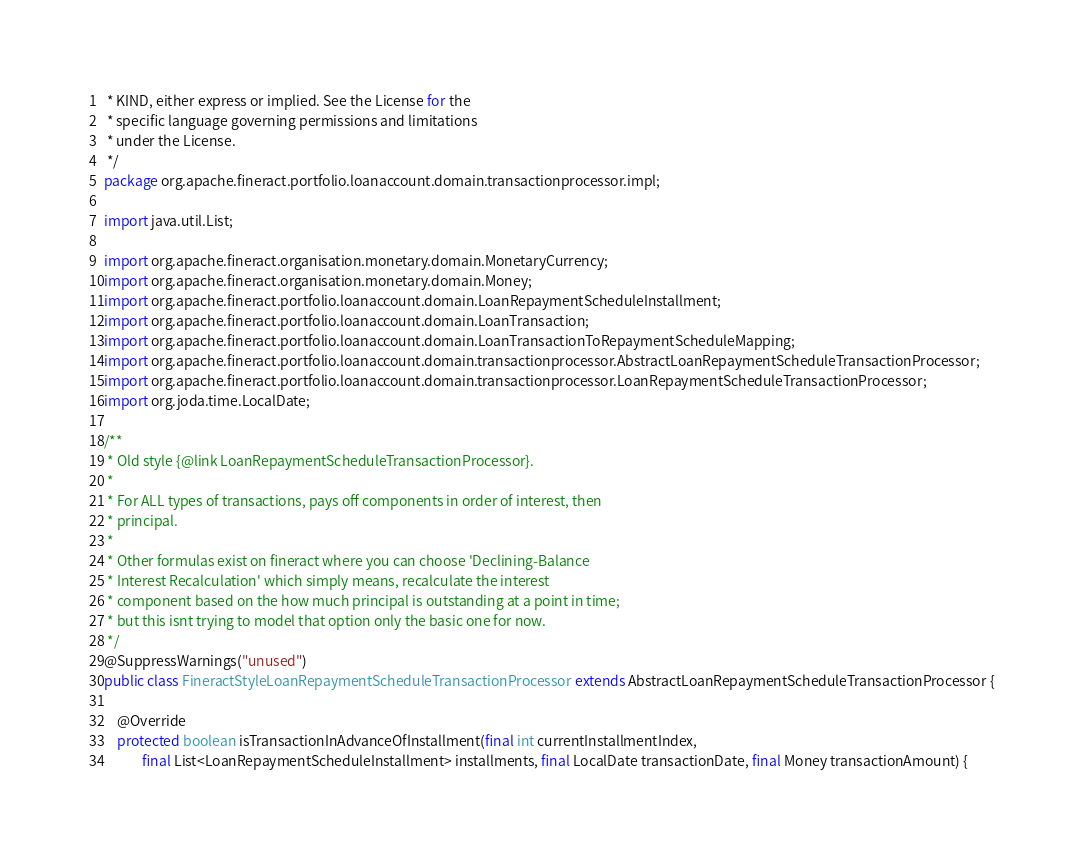Convert code to text. <code><loc_0><loc_0><loc_500><loc_500><_Java_> * KIND, either express or implied. See the License for the
 * specific language governing permissions and limitations
 * under the License.
 */
package org.apache.fineract.portfolio.loanaccount.domain.transactionprocessor.impl;

import java.util.List;

import org.apache.fineract.organisation.monetary.domain.MonetaryCurrency;
import org.apache.fineract.organisation.monetary.domain.Money;
import org.apache.fineract.portfolio.loanaccount.domain.LoanRepaymentScheduleInstallment;
import org.apache.fineract.portfolio.loanaccount.domain.LoanTransaction;
import org.apache.fineract.portfolio.loanaccount.domain.LoanTransactionToRepaymentScheduleMapping;
import org.apache.fineract.portfolio.loanaccount.domain.transactionprocessor.AbstractLoanRepaymentScheduleTransactionProcessor;
import org.apache.fineract.portfolio.loanaccount.domain.transactionprocessor.LoanRepaymentScheduleTransactionProcessor;
import org.joda.time.LocalDate;

/**
 * Old style {@link LoanRepaymentScheduleTransactionProcessor}.
 * 
 * For ALL types of transactions, pays off components in order of interest, then
 * principal.
 * 
 * Other formulas exist on fineract where you can choose 'Declining-Balance
 * Interest Recalculation' which simply means, recalculate the interest
 * component based on the how much principal is outstanding at a point in time;
 * but this isnt trying to model that option only the basic one for now.
 */
@SuppressWarnings("unused")
public class FineractStyleLoanRepaymentScheduleTransactionProcessor extends AbstractLoanRepaymentScheduleTransactionProcessor {

    @Override
    protected boolean isTransactionInAdvanceOfInstallment(final int currentInstallmentIndex,
            final List<LoanRepaymentScheduleInstallment> installments, final LocalDate transactionDate, final Money transactionAmount) {
</code> 